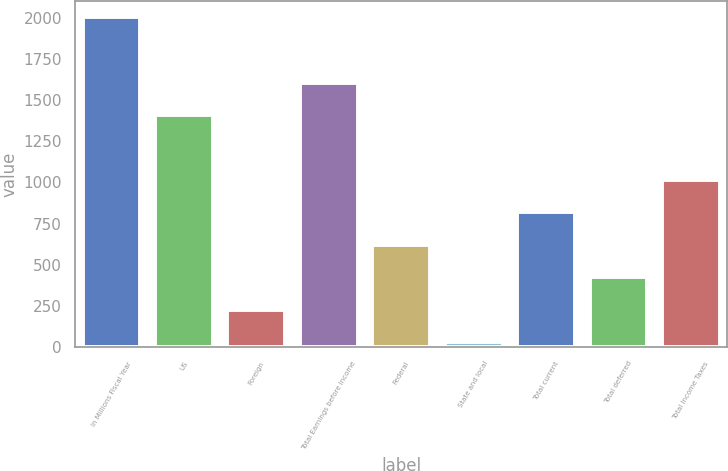Convert chart to OTSL. <chart><loc_0><loc_0><loc_500><loc_500><bar_chart><fcel>In Millions Fiscal Year<fcel>US<fcel>Foreign<fcel>Total Earnings before Income<fcel>Federal<fcel>State and local<fcel>Total current<fcel>Total deferred<fcel>Total Income Taxes<nl><fcel>2004<fcel>1408<fcel>228.3<fcel>1605.3<fcel>622.9<fcel>31<fcel>820.2<fcel>425.6<fcel>1017.5<nl></chart> 